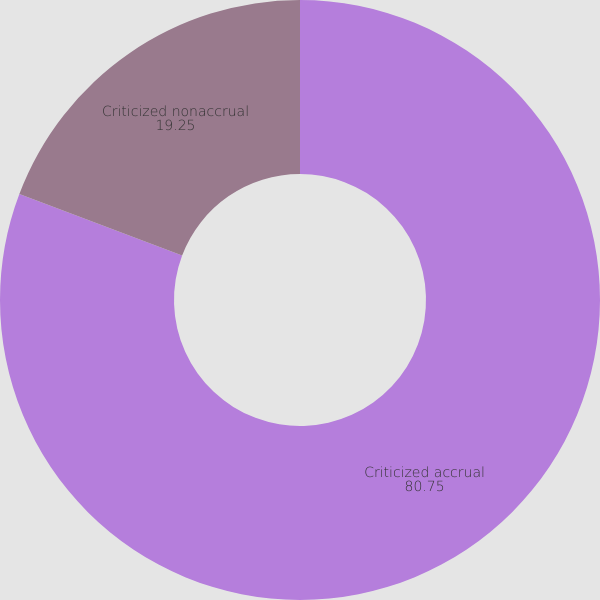Convert chart to OTSL. <chart><loc_0><loc_0><loc_500><loc_500><pie_chart><fcel>Criticized accrual<fcel>Criticized nonaccrual<nl><fcel>80.75%<fcel>19.25%<nl></chart> 